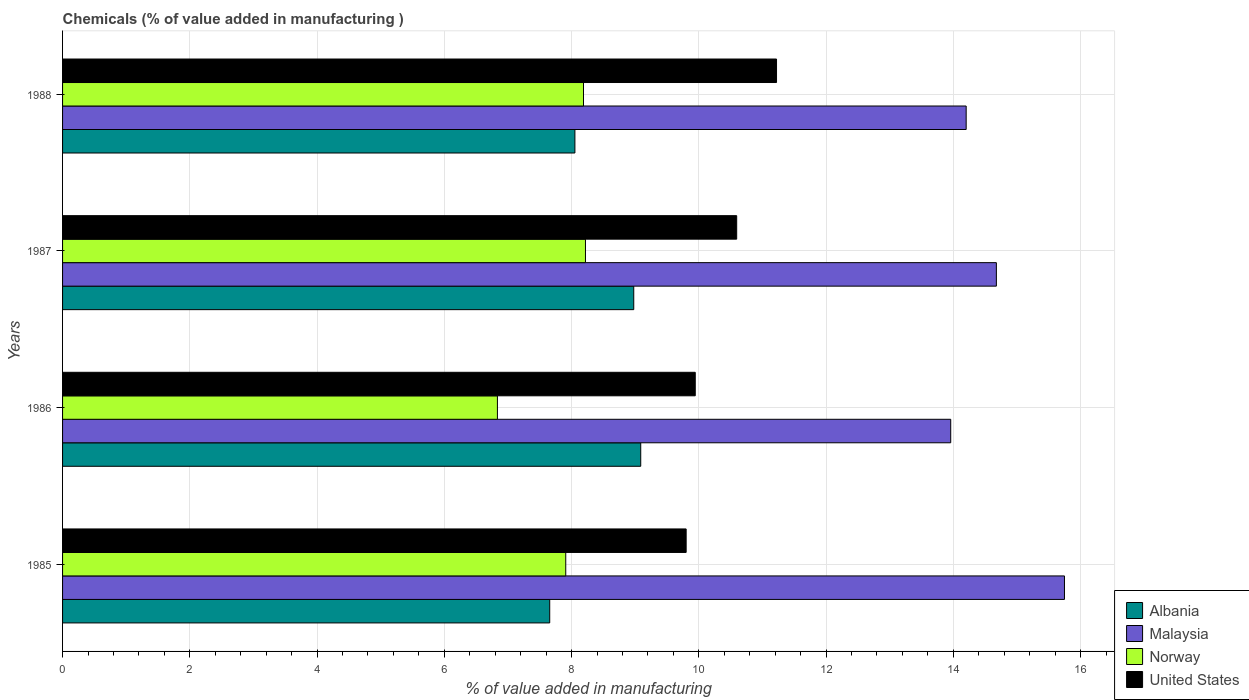How many groups of bars are there?
Offer a very short reply. 4. Are the number of bars per tick equal to the number of legend labels?
Offer a very short reply. Yes. What is the label of the 1st group of bars from the top?
Ensure brevity in your answer.  1988. What is the value added in manufacturing chemicals in Albania in 1987?
Offer a terse response. 8.98. Across all years, what is the maximum value added in manufacturing chemicals in Malaysia?
Offer a very short reply. 15.75. Across all years, what is the minimum value added in manufacturing chemicals in Norway?
Your answer should be very brief. 6.83. In which year was the value added in manufacturing chemicals in Malaysia minimum?
Your response must be concise. 1986. What is the total value added in manufacturing chemicals in United States in the graph?
Your response must be concise. 41.56. What is the difference between the value added in manufacturing chemicals in Malaysia in 1985 and that in 1988?
Your answer should be very brief. 1.55. What is the difference between the value added in manufacturing chemicals in Malaysia in 1987 and the value added in manufacturing chemicals in Norway in 1988?
Offer a very short reply. 6.49. What is the average value added in manufacturing chemicals in United States per year?
Offer a terse response. 10.39. In the year 1985, what is the difference between the value added in manufacturing chemicals in Malaysia and value added in manufacturing chemicals in United States?
Make the answer very short. 5.95. In how many years, is the value added in manufacturing chemicals in Norway greater than 15.6 %?
Your answer should be compact. 0. What is the ratio of the value added in manufacturing chemicals in United States in 1987 to that in 1988?
Provide a succinct answer. 0.94. Is the value added in manufacturing chemicals in Malaysia in 1987 less than that in 1988?
Your answer should be very brief. No. Is the difference between the value added in manufacturing chemicals in Malaysia in 1985 and 1987 greater than the difference between the value added in manufacturing chemicals in United States in 1985 and 1987?
Offer a very short reply. Yes. What is the difference between the highest and the second highest value added in manufacturing chemicals in Albania?
Provide a succinct answer. 0.11. What is the difference between the highest and the lowest value added in manufacturing chemicals in United States?
Offer a very short reply. 1.42. In how many years, is the value added in manufacturing chemicals in Norway greater than the average value added in manufacturing chemicals in Norway taken over all years?
Your answer should be very brief. 3. Is the sum of the value added in manufacturing chemicals in Albania in 1985 and 1987 greater than the maximum value added in manufacturing chemicals in Malaysia across all years?
Offer a terse response. Yes. What does the 4th bar from the top in 1987 represents?
Offer a very short reply. Albania. What does the 2nd bar from the bottom in 1987 represents?
Your answer should be very brief. Malaysia. Are all the bars in the graph horizontal?
Your answer should be very brief. Yes. How many years are there in the graph?
Your answer should be compact. 4. Are the values on the major ticks of X-axis written in scientific E-notation?
Provide a short and direct response. No. Does the graph contain grids?
Keep it short and to the point. Yes. How many legend labels are there?
Ensure brevity in your answer.  4. What is the title of the graph?
Provide a succinct answer. Chemicals (% of value added in manufacturing ). What is the label or title of the X-axis?
Your answer should be compact. % of value added in manufacturing. What is the label or title of the Y-axis?
Offer a very short reply. Years. What is the % of value added in manufacturing of Albania in 1985?
Offer a very short reply. 7.66. What is the % of value added in manufacturing in Malaysia in 1985?
Provide a short and direct response. 15.75. What is the % of value added in manufacturing of Norway in 1985?
Your answer should be very brief. 7.91. What is the % of value added in manufacturing of United States in 1985?
Your answer should be compact. 9.8. What is the % of value added in manufacturing in Albania in 1986?
Make the answer very short. 9.09. What is the % of value added in manufacturing of Malaysia in 1986?
Ensure brevity in your answer.  13.96. What is the % of value added in manufacturing in Norway in 1986?
Give a very brief answer. 6.83. What is the % of value added in manufacturing in United States in 1986?
Your response must be concise. 9.94. What is the % of value added in manufacturing in Albania in 1987?
Your answer should be very brief. 8.98. What is the % of value added in manufacturing in Malaysia in 1987?
Make the answer very short. 14.68. What is the % of value added in manufacturing of Norway in 1987?
Make the answer very short. 8.22. What is the % of value added in manufacturing of United States in 1987?
Provide a short and direct response. 10.6. What is the % of value added in manufacturing of Albania in 1988?
Your answer should be compact. 8.05. What is the % of value added in manufacturing in Malaysia in 1988?
Ensure brevity in your answer.  14.2. What is the % of value added in manufacturing of Norway in 1988?
Keep it short and to the point. 8.19. What is the % of value added in manufacturing of United States in 1988?
Your answer should be very brief. 11.22. Across all years, what is the maximum % of value added in manufacturing of Albania?
Ensure brevity in your answer.  9.09. Across all years, what is the maximum % of value added in manufacturing of Malaysia?
Your response must be concise. 15.75. Across all years, what is the maximum % of value added in manufacturing in Norway?
Provide a succinct answer. 8.22. Across all years, what is the maximum % of value added in manufacturing in United States?
Your answer should be compact. 11.22. Across all years, what is the minimum % of value added in manufacturing in Albania?
Provide a short and direct response. 7.66. Across all years, what is the minimum % of value added in manufacturing in Malaysia?
Provide a short and direct response. 13.96. Across all years, what is the minimum % of value added in manufacturing in Norway?
Your answer should be very brief. 6.83. Across all years, what is the minimum % of value added in manufacturing in United States?
Ensure brevity in your answer.  9.8. What is the total % of value added in manufacturing in Albania in the graph?
Your answer should be very brief. 33.77. What is the total % of value added in manufacturing of Malaysia in the graph?
Your answer should be very brief. 58.59. What is the total % of value added in manufacturing of Norway in the graph?
Offer a very short reply. 31.15. What is the total % of value added in manufacturing of United States in the graph?
Ensure brevity in your answer.  41.56. What is the difference between the % of value added in manufacturing of Albania in 1985 and that in 1986?
Offer a very short reply. -1.43. What is the difference between the % of value added in manufacturing in Malaysia in 1985 and that in 1986?
Make the answer very short. 1.79. What is the difference between the % of value added in manufacturing in Norway in 1985 and that in 1986?
Make the answer very short. 1.07. What is the difference between the % of value added in manufacturing in United States in 1985 and that in 1986?
Your answer should be compact. -0.14. What is the difference between the % of value added in manufacturing of Albania in 1985 and that in 1987?
Offer a terse response. -1.32. What is the difference between the % of value added in manufacturing of Malaysia in 1985 and that in 1987?
Ensure brevity in your answer.  1.07. What is the difference between the % of value added in manufacturing of Norway in 1985 and that in 1987?
Keep it short and to the point. -0.31. What is the difference between the % of value added in manufacturing in United States in 1985 and that in 1987?
Ensure brevity in your answer.  -0.79. What is the difference between the % of value added in manufacturing in Albania in 1985 and that in 1988?
Ensure brevity in your answer.  -0.4. What is the difference between the % of value added in manufacturing in Malaysia in 1985 and that in 1988?
Offer a terse response. 1.55. What is the difference between the % of value added in manufacturing in Norway in 1985 and that in 1988?
Offer a terse response. -0.28. What is the difference between the % of value added in manufacturing of United States in 1985 and that in 1988?
Give a very brief answer. -1.42. What is the difference between the % of value added in manufacturing in Albania in 1986 and that in 1987?
Ensure brevity in your answer.  0.11. What is the difference between the % of value added in manufacturing in Malaysia in 1986 and that in 1987?
Ensure brevity in your answer.  -0.72. What is the difference between the % of value added in manufacturing in Norway in 1986 and that in 1987?
Keep it short and to the point. -1.38. What is the difference between the % of value added in manufacturing in United States in 1986 and that in 1987?
Your answer should be very brief. -0.65. What is the difference between the % of value added in manufacturing in Albania in 1986 and that in 1988?
Keep it short and to the point. 1.03. What is the difference between the % of value added in manufacturing of Malaysia in 1986 and that in 1988?
Your answer should be very brief. -0.24. What is the difference between the % of value added in manufacturing in Norway in 1986 and that in 1988?
Provide a succinct answer. -1.35. What is the difference between the % of value added in manufacturing of United States in 1986 and that in 1988?
Your answer should be compact. -1.28. What is the difference between the % of value added in manufacturing in Albania in 1987 and that in 1988?
Your answer should be compact. 0.92. What is the difference between the % of value added in manufacturing of Malaysia in 1987 and that in 1988?
Your answer should be very brief. 0.47. What is the difference between the % of value added in manufacturing of Norway in 1987 and that in 1988?
Keep it short and to the point. 0.03. What is the difference between the % of value added in manufacturing of United States in 1987 and that in 1988?
Offer a very short reply. -0.63. What is the difference between the % of value added in manufacturing in Albania in 1985 and the % of value added in manufacturing in Malaysia in 1986?
Keep it short and to the point. -6.3. What is the difference between the % of value added in manufacturing of Albania in 1985 and the % of value added in manufacturing of Norway in 1986?
Ensure brevity in your answer.  0.82. What is the difference between the % of value added in manufacturing of Albania in 1985 and the % of value added in manufacturing of United States in 1986?
Offer a terse response. -2.29. What is the difference between the % of value added in manufacturing of Malaysia in 1985 and the % of value added in manufacturing of Norway in 1986?
Offer a terse response. 8.91. What is the difference between the % of value added in manufacturing in Malaysia in 1985 and the % of value added in manufacturing in United States in 1986?
Make the answer very short. 5.8. What is the difference between the % of value added in manufacturing of Norway in 1985 and the % of value added in manufacturing of United States in 1986?
Make the answer very short. -2.04. What is the difference between the % of value added in manufacturing in Albania in 1985 and the % of value added in manufacturing in Malaysia in 1987?
Give a very brief answer. -7.02. What is the difference between the % of value added in manufacturing in Albania in 1985 and the % of value added in manufacturing in Norway in 1987?
Ensure brevity in your answer.  -0.56. What is the difference between the % of value added in manufacturing of Albania in 1985 and the % of value added in manufacturing of United States in 1987?
Give a very brief answer. -2.94. What is the difference between the % of value added in manufacturing in Malaysia in 1985 and the % of value added in manufacturing in Norway in 1987?
Keep it short and to the point. 7.53. What is the difference between the % of value added in manufacturing of Malaysia in 1985 and the % of value added in manufacturing of United States in 1987?
Your answer should be very brief. 5.15. What is the difference between the % of value added in manufacturing of Norway in 1985 and the % of value added in manufacturing of United States in 1987?
Provide a succinct answer. -2.69. What is the difference between the % of value added in manufacturing of Albania in 1985 and the % of value added in manufacturing of Malaysia in 1988?
Offer a very short reply. -6.55. What is the difference between the % of value added in manufacturing of Albania in 1985 and the % of value added in manufacturing of Norway in 1988?
Provide a short and direct response. -0.53. What is the difference between the % of value added in manufacturing of Albania in 1985 and the % of value added in manufacturing of United States in 1988?
Offer a very short reply. -3.56. What is the difference between the % of value added in manufacturing in Malaysia in 1985 and the % of value added in manufacturing in Norway in 1988?
Provide a short and direct response. 7.56. What is the difference between the % of value added in manufacturing of Malaysia in 1985 and the % of value added in manufacturing of United States in 1988?
Provide a short and direct response. 4.53. What is the difference between the % of value added in manufacturing in Norway in 1985 and the % of value added in manufacturing in United States in 1988?
Your response must be concise. -3.31. What is the difference between the % of value added in manufacturing in Albania in 1986 and the % of value added in manufacturing in Malaysia in 1987?
Provide a short and direct response. -5.59. What is the difference between the % of value added in manufacturing in Albania in 1986 and the % of value added in manufacturing in Norway in 1987?
Make the answer very short. 0.87. What is the difference between the % of value added in manufacturing in Albania in 1986 and the % of value added in manufacturing in United States in 1987?
Make the answer very short. -1.51. What is the difference between the % of value added in manufacturing of Malaysia in 1986 and the % of value added in manufacturing of Norway in 1987?
Offer a terse response. 5.74. What is the difference between the % of value added in manufacturing of Malaysia in 1986 and the % of value added in manufacturing of United States in 1987?
Your response must be concise. 3.36. What is the difference between the % of value added in manufacturing of Norway in 1986 and the % of value added in manufacturing of United States in 1987?
Keep it short and to the point. -3.76. What is the difference between the % of value added in manufacturing of Albania in 1986 and the % of value added in manufacturing of Malaysia in 1988?
Provide a short and direct response. -5.11. What is the difference between the % of value added in manufacturing in Albania in 1986 and the % of value added in manufacturing in Norway in 1988?
Your answer should be very brief. 0.9. What is the difference between the % of value added in manufacturing in Albania in 1986 and the % of value added in manufacturing in United States in 1988?
Ensure brevity in your answer.  -2.13. What is the difference between the % of value added in manufacturing of Malaysia in 1986 and the % of value added in manufacturing of Norway in 1988?
Your response must be concise. 5.77. What is the difference between the % of value added in manufacturing in Malaysia in 1986 and the % of value added in manufacturing in United States in 1988?
Keep it short and to the point. 2.74. What is the difference between the % of value added in manufacturing of Norway in 1986 and the % of value added in manufacturing of United States in 1988?
Provide a succinct answer. -4.39. What is the difference between the % of value added in manufacturing in Albania in 1987 and the % of value added in manufacturing in Malaysia in 1988?
Make the answer very short. -5.22. What is the difference between the % of value added in manufacturing in Albania in 1987 and the % of value added in manufacturing in Norway in 1988?
Make the answer very short. 0.79. What is the difference between the % of value added in manufacturing in Albania in 1987 and the % of value added in manufacturing in United States in 1988?
Your answer should be compact. -2.24. What is the difference between the % of value added in manufacturing of Malaysia in 1987 and the % of value added in manufacturing of Norway in 1988?
Your answer should be compact. 6.49. What is the difference between the % of value added in manufacturing in Malaysia in 1987 and the % of value added in manufacturing in United States in 1988?
Your response must be concise. 3.46. What is the difference between the % of value added in manufacturing in Norway in 1987 and the % of value added in manufacturing in United States in 1988?
Offer a terse response. -3. What is the average % of value added in manufacturing in Albania per year?
Give a very brief answer. 8.44. What is the average % of value added in manufacturing in Malaysia per year?
Your answer should be compact. 14.65. What is the average % of value added in manufacturing in Norway per year?
Offer a terse response. 7.79. What is the average % of value added in manufacturing in United States per year?
Keep it short and to the point. 10.39. In the year 1985, what is the difference between the % of value added in manufacturing in Albania and % of value added in manufacturing in Malaysia?
Your answer should be compact. -8.09. In the year 1985, what is the difference between the % of value added in manufacturing of Albania and % of value added in manufacturing of Norway?
Make the answer very short. -0.25. In the year 1985, what is the difference between the % of value added in manufacturing in Albania and % of value added in manufacturing in United States?
Offer a terse response. -2.14. In the year 1985, what is the difference between the % of value added in manufacturing in Malaysia and % of value added in manufacturing in Norway?
Your answer should be compact. 7.84. In the year 1985, what is the difference between the % of value added in manufacturing in Malaysia and % of value added in manufacturing in United States?
Your answer should be very brief. 5.95. In the year 1985, what is the difference between the % of value added in manufacturing of Norway and % of value added in manufacturing of United States?
Make the answer very short. -1.89. In the year 1986, what is the difference between the % of value added in manufacturing in Albania and % of value added in manufacturing in Malaysia?
Ensure brevity in your answer.  -4.87. In the year 1986, what is the difference between the % of value added in manufacturing in Albania and % of value added in manufacturing in Norway?
Keep it short and to the point. 2.25. In the year 1986, what is the difference between the % of value added in manufacturing of Albania and % of value added in manufacturing of United States?
Keep it short and to the point. -0.86. In the year 1986, what is the difference between the % of value added in manufacturing in Malaysia and % of value added in manufacturing in Norway?
Provide a succinct answer. 7.12. In the year 1986, what is the difference between the % of value added in manufacturing of Malaysia and % of value added in manufacturing of United States?
Offer a terse response. 4.02. In the year 1986, what is the difference between the % of value added in manufacturing in Norway and % of value added in manufacturing in United States?
Keep it short and to the point. -3.11. In the year 1987, what is the difference between the % of value added in manufacturing in Albania and % of value added in manufacturing in Malaysia?
Provide a succinct answer. -5.7. In the year 1987, what is the difference between the % of value added in manufacturing in Albania and % of value added in manufacturing in Norway?
Give a very brief answer. 0.76. In the year 1987, what is the difference between the % of value added in manufacturing in Albania and % of value added in manufacturing in United States?
Your answer should be very brief. -1.62. In the year 1987, what is the difference between the % of value added in manufacturing of Malaysia and % of value added in manufacturing of Norway?
Your answer should be very brief. 6.46. In the year 1987, what is the difference between the % of value added in manufacturing of Malaysia and % of value added in manufacturing of United States?
Give a very brief answer. 4.08. In the year 1987, what is the difference between the % of value added in manufacturing of Norway and % of value added in manufacturing of United States?
Your answer should be compact. -2.38. In the year 1988, what is the difference between the % of value added in manufacturing of Albania and % of value added in manufacturing of Malaysia?
Keep it short and to the point. -6.15. In the year 1988, what is the difference between the % of value added in manufacturing in Albania and % of value added in manufacturing in Norway?
Provide a short and direct response. -0.14. In the year 1988, what is the difference between the % of value added in manufacturing in Albania and % of value added in manufacturing in United States?
Your response must be concise. -3.17. In the year 1988, what is the difference between the % of value added in manufacturing of Malaysia and % of value added in manufacturing of Norway?
Provide a short and direct response. 6.01. In the year 1988, what is the difference between the % of value added in manufacturing of Malaysia and % of value added in manufacturing of United States?
Keep it short and to the point. 2.98. In the year 1988, what is the difference between the % of value added in manufacturing in Norway and % of value added in manufacturing in United States?
Offer a terse response. -3.03. What is the ratio of the % of value added in manufacturing of Albania in 1985 to that in 1986?
Offer a very short reply. 0.84. What is the ratio of the % of value added in manufacturing in Malaysia in 1985 to that in 1986?
Your answer should be very brief. 1.13. What is the ratio of the % of value added in manufacturing of Norway in 1985 to that in 1986?
Give a very brief answer. 1.16. What is the ratio of the % of value added in manufacturing in United States in 1985 to that in 1986?
Keep it short and to the point. 0.99. What is the ratio of the % of value added in manufacturing of Albania in 1985 to that in 1987?
Make the answer very short. 0.85. What is the ratio of the % of value added in manufacturing of Malaysia in 1985 to that in 1987?
Your answer should be compact. 1.07. What is the ratio of the % of value added in manufacturing in Norway in 1985 to that in 1987?
Offer a very short reply. 0.96. What is the ratio of the % of value added in manufacturing of United States in 1985 to that in 1987?
Give a very brief answer. 0.93. What is the ratio of the % of value added in manufacturing of Albania in 1985 to that in 1988?
Provide a succinct answer. 0.95. What is the ratio of the % of value added in manufacturing in Malaysia in 1985 to that in 1988?
Offer a very short reply. 1.11. What is the ratio of the % of value added in manufacturing of Norway in 1985 to that in 1988?
Your response must be concise. 0.97. What is the ratio of the % of value added in manufacturing of United States in 1985 to that in 1988?
Keep it short and to the point. 0.87. What is the ratio of the % of value added in manufacturing in Albania in 1986 to that in 1987?
Your response must be concise. 1.01. What is the ratio of the % of value added in manufacturing of Malaysia in 1986 to that in 1987?
Give a very brief answer. 0.95. What is the ratio of the % of value added in manufacturing of Norway in 1986 to that in 1987?
Make the answer very short. 0.83. What is the ratio of the % of value added in manufacturing in United States in 1986 to that in 1987?
Provide a succinct answer. 0.94. What is the ratio of the % of value added in manufacturing in Albania in 1986 to that in 1988?
Offer a terse response. 1.13. What is the ratio of the % of value added in manufacturing of Malaysia in 1986 to that in 1988?
Your response must be concise. 0.98. What is the ratio of the % of value added in manufacturing of Norway in 1986 to that in 1988?
Provide a succinct answer. 0.83. What is the ratio of the % of value added in manufacturing in United States in 1986 to that in 1988?
Your response must be concise. 0.89. What is the ratio of the % of value added in manufacturing of Albania in 1987 to that in 1988?
Ensure brevity in your answer.  1.11. What is the ratio of the % of value added in manufacturing in Malaysia in 1987 to that in 1988?
Your answer should be compact. 1.03. What is the ratio of the % of value added in manufacturing of Norway in 1987 to that in 1988?
Ensure brevity in your answer.  1. What is the ratio of the % of value added in manufacturing in United States in 1987 to that in 1988?
Your response must be concise. 0.94. What is the difference between the highest and the second highest % of value added in manufacturing in Albania?
Ensure brevity in your answer.  0.11. What is the difference between the highest and the second highest % of value added in manufacturing of Malaysia?
Provide a succinct answer. 1.07. What is the difference between the highest and the second highest % of value added in manufacturing in Norway?
Your answer should be very brief. 0.03. What is the difference between the highest and the second highest % of value added in manufacturing of United States?
Offer a terse response. 0.63. What is the difference between the highest and the lowest % of value added in manufacturing of Albania?
Give a very brief answer. 1.43. What is the difference between the highest and the lowest % of value added in manufacturing of Malaysia?
Your answer should be compact. 1.79. What is the difference between the highest and the lowest % of value added in manufacturing in Norway?
Make the answer very short. 1.38. What is the difference between the highest and the lowest % of value added in manufacturing in United States?
Your response must be concise. 1.42. 